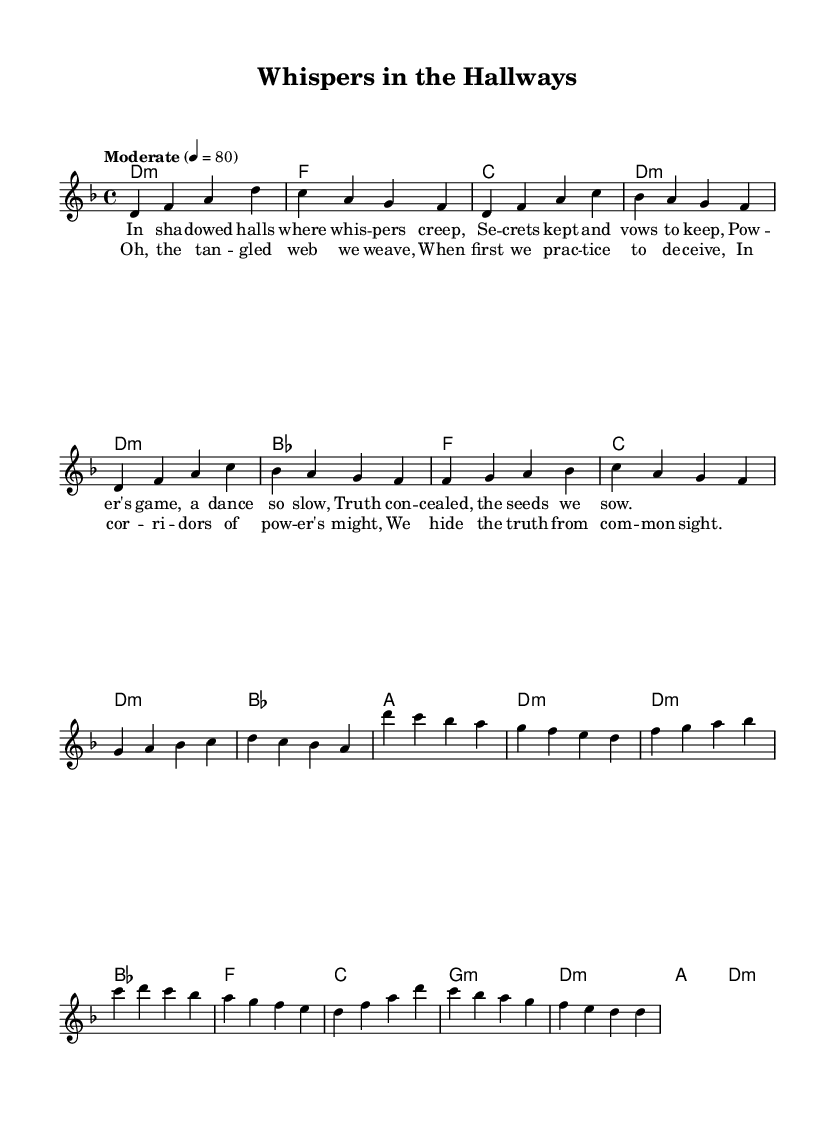What is the key signature of this music? The key signature is indicated at the beginning of the score. The presence of a flat on the B note shows that the key is D minor, which is characterized by one flat.
Answer: D minor What is the time signature of this piece? The time signature is found at the beginning of the score as well. It is represented as four beats per measure, which is denoted by "4/4".
Answer: 4/4 What is the tempo marking for this composition? The tempo marking is clearly written above the staff. It states "Moderate" with a metronome marking of 80 beats per minute.
Answer: Moderate 4 = 80 How many measures are in the verse? To determine the number of measures in the verse, we count the measures in the verse section of the sheet music. There are a total of four measures in the verse.
Answer: 4 What is the primary theme of the lyrics in this folk ballad? The lyrics are focused on power and deception within political contexts, as indicated by phrases such as "Whispers in the Hallways" and references to hidden truths.
Answer: Power and deception How does the chorus structure relate to traditional folk music? The chorus employs a repetitive and memorable structure, common in folk music, allowing for easy sing-along and emphasizing the message of deception woven into its lyrics, thus maintaining engagement.
Answer: Repetitive structure Which musical element emphasizes the theme of deception in the ballad? The use of minor chords and the lyrical content highlighting secrets and truths concealed are key musical elements that underscore the theme of deception effectively in the piece.
Answer: Minor chords 